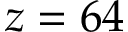Convert formula to latex. <formula><loc_0><loc_0><loc_500><loc_500>z = 6 4</formula> 